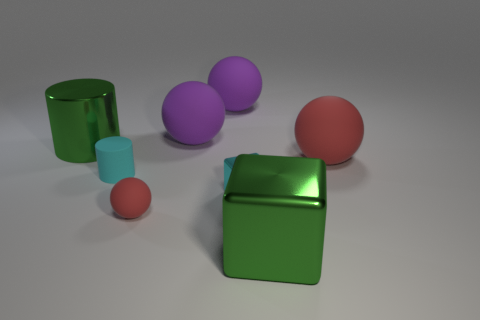Are there fewer big green cylinders than tiny green spheres? no 